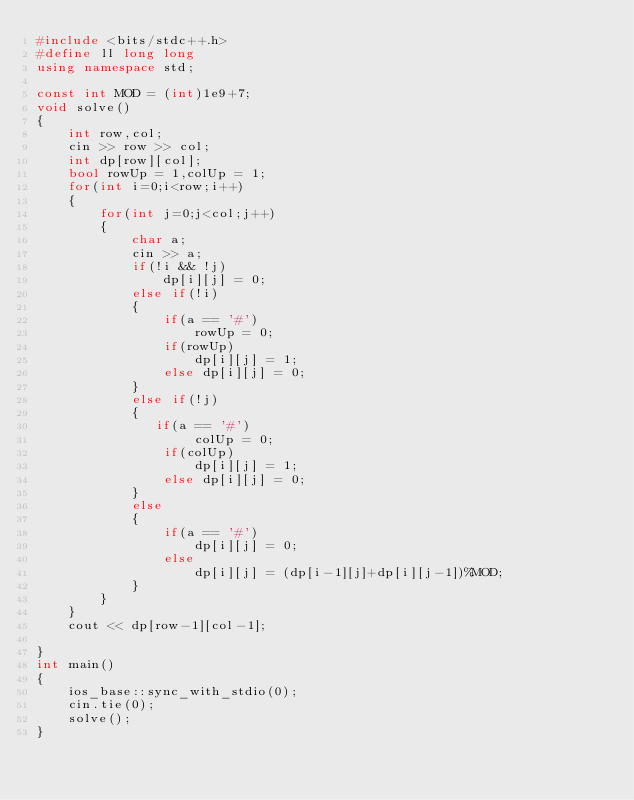Convert code to text. <code><loc_0><loc_0><loc_500><loc_500><_C++_>#include <bits/stdc++.h>
#define ll long long
using namespace std;

const int MOD = (int)1e9+7;
void solve()
{
    int row,col;
    cin >> row >> col;
    int dp[row][col];
    bool rowUp = 1,colUp = 1;
    for(int i=0;i<row;i++)
    {
        for(int j=0;j<col;j++)
        {
            char a;
            cin >> a;
            if(!i && !j)
                dp[i][j] = 0;
            else if(!i)
            {
                if(a == '#')
                    rowUp = 0;
                if(rowUp)
                    dp[i][j] = 1;
                else dp[i][j] = 0;
            }
            else if(!j)
            {
               if(a == '#')
                    colUp = 0;
                if(colUp)
                    dp[i][j] = 1;
                else dp[i][j] = 0;
            }
            else
            {
                if(a == '#')
                    dp[i][j] = 0;
                else
                    dp[i][j] = (dp[i-1][j]+dp[i][j-1])%MOD;
            }
        }
    }
    cout << dp[row-1][col-1];
    
}
int main()
{
    ios_base::sync_with_stdio(0);
    cin.tie(0);
    solve();
}</code> 